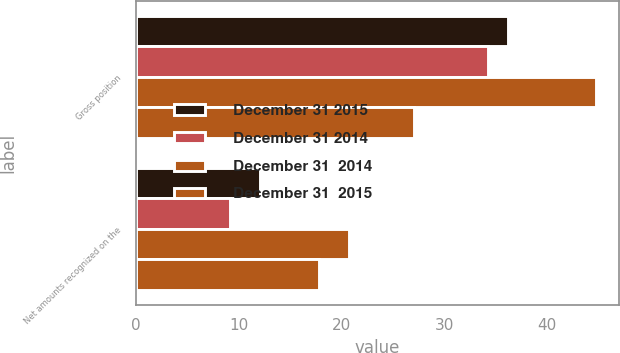Convert chart to OTSL. <chart><loc_0><loc_0><loc_500><loc_500><stacked_bar_chart><ecel><fcel>Gross position<fcel>Net amounts recognized on the<nl><fcel>December 31 2015<fcel>36.2<fcel>12.1<nl><fcel>December 31 2014<fcel>34.3<fcel>9.1<nl><fcel>December 31  2014<fcel>44.8<fcel>20.7<nl><fcel>December 31  2015<fcel>27.1<fcel>17.8<nl></chart> 